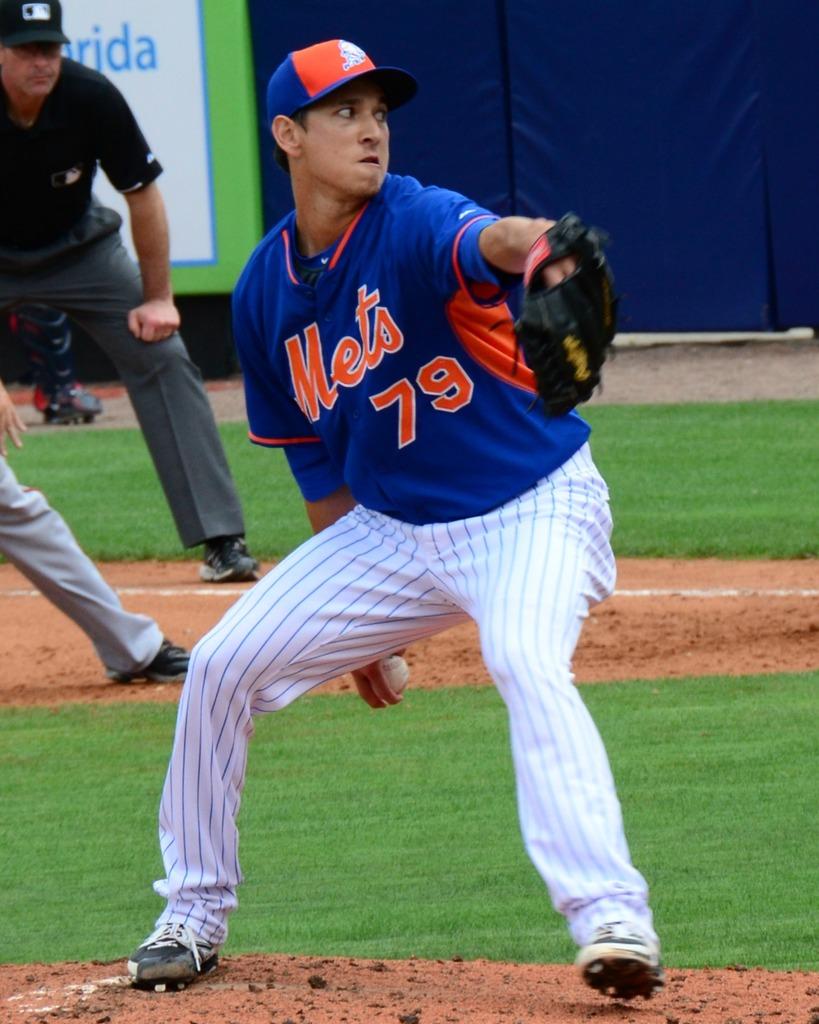What is the number on the jersey?
Your response must be concise. 79. What team does he play for?
Give a very brief answer. Mets. 